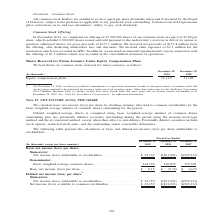According to Sunpower Corporation's financial document, How was the basic net income (loss) per share calculated? By dividing earnings allocated to common stockholders by the basic weighted-average number of common shares outstanding for the period.. The document states: "We calculate basic net income (loss) per share by dividing earnings allocated to common stockholders by the basic weighted-average number of common sh..." Also, What does potentially dilutive securities consist of? Stock options, restricted stock units, and the outstanding senior convertible debentures.. The document states: "-dilutive. Potentially dilutive securities include stock options, restricted stock units, and the outstanding senior convertible debentures...." Also, In which years was the calculation of basic and diluted net income (loss) per share attributable to stockholders recorded for? The document contains multiple relevant values: 2019, 2018, 2017. From the document: "December 29, 2019 December 30, 2018 December 31, 2017 thousands, except per share amounts) December 29, 2019 December 30, 2018 December 31, 2017 per s..." Additionally, In which year is the dilutive net income  per share the highest? According to the financial document, 2019. The relevant text states: "thousands, except per share amounts) December 29, 2019 December 30, 2018 December 31, 2017..." Also, can you calculate: What is the change in dilutive weighted-average common shares from 2018 to 2019? Based on the calculation: 147,525 - 140,825 , the result is 6700 (in thousands). This is based on the information: "r: Basic weighted-average common shares . 144,796 140,825 139,370..." The key data points involved are: 140,825, 147,525. Also, can you calculate: What is the percentage change in dilutive weighted-average common shares from 2017 to 2019? To answer this question, I need to perform calculations using the financial data. The calculation is: (147,525 - 139,370)/139,370 , which equals 5.85 (percentage). This is based on the information: "weighted-average common shares . 144,796 140,825 139,370..." The key data points involved are: 139,370, 147,525. 